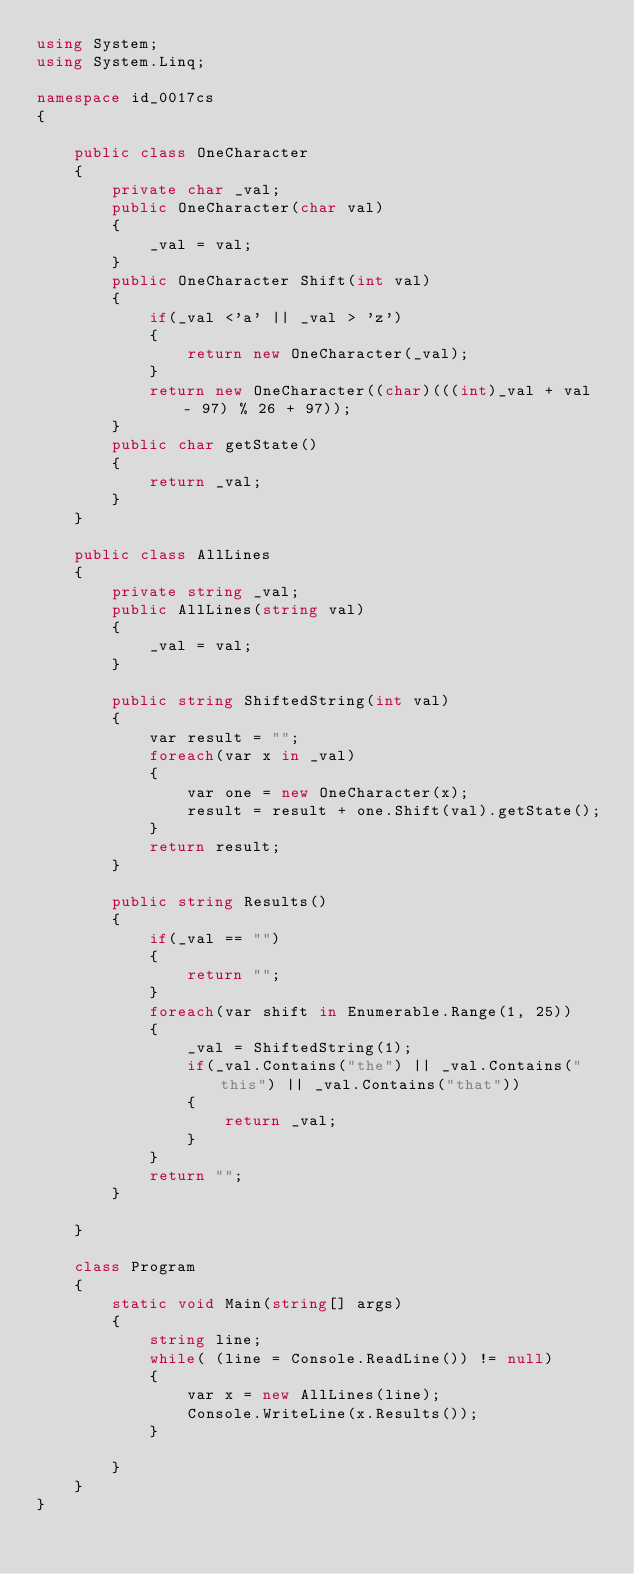<code> <loc_0><loc_0><loc_500><loc_500><_C#_>using System;
using System.Linq;

namespace id_0017cs
{

    public class OneCharacter
    {
        private char _val;
        public OneCharacter(char val)
        {
            _val = val;
        }
        public OneCharacter Shift(int val)
        {
            if(_val <'a' || _val > 'z')
            {
                return new OneCharacter(_val);
            }
            return new OneCharacter((char)(((int)_val + val - 97) % 26 + 97));
        }
        public char getState()
        {
            return _val;
        }
    }

    public class AllLines
    {
        private string _val;
        public AllLines(string val)
        {
            _val = val;
        }
        
        public string ShiftedString(int val)
        {
            var result = "";
            foreach(var x in _val)
            {
                var one = new OneCharacter(x);
                result = result + one.Shift(val).getState();
            }
            return result;
        }

        public string Results()
        {
            if(_val == "")
            {
                return "";
            }
            foreach(var shift in Enumerable.Range(1, 25))
            {
                _val = ShiftedString(1);
                if(_val.Contains("the") || _val.Contains("this") || _val.Contains("that"))
                {
                    return _val;
                }
            }
            return "";
        }

    }

    class Program
    {
        static void Main(string[] args)
        {
            string line;
            while( (line = Console.ReadLine()) != null)
            {
                var x = new AllLines(line);
                Console.WriteLine(x.Results());
            }

        }
    }
}

</code> 